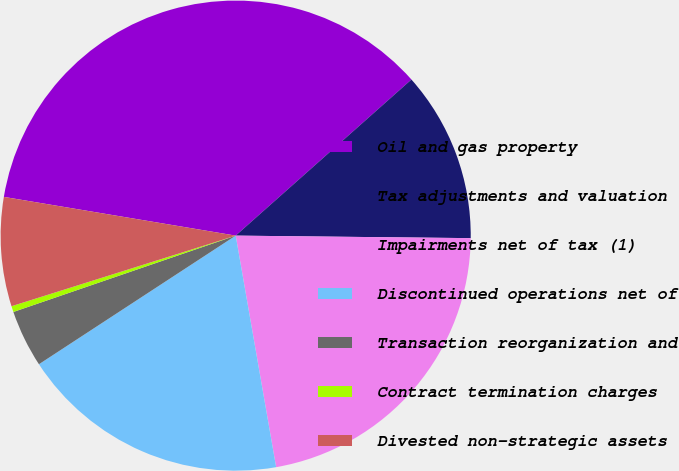Convert chart. <chart><loc_0><loc_0><loc_500><loc_500><pie_chart><fcel>Oil and gas property<fcel>Tax adjustments and valuation<fcel>Impairments net of tax (1)<fcel>Discontinued operations net of<fcel>Transaction reorganization and<fcel>Contract termination charges<fcel>Divested non-strategic assets<nl><fcel>35.81%<fcel>11.73%<fcel>22.08%<fcel>18.54%<fcel>3.95%<fcel>0.41%<fcel>7.49%<nl></chart> 